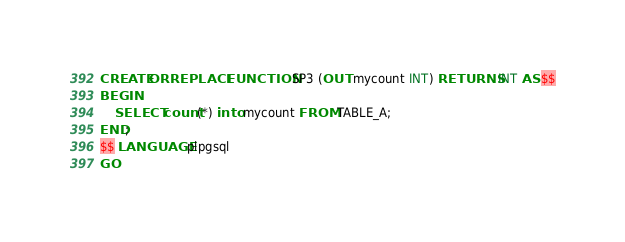<code> <loc_0><loc_0><loc_500><loc_500><_SQL_>CREATE OR REPLACE FUNCTION SP3 (OUT mycount INT) RETURNS INT AS $$
BEGIN
    SELECT count(*) into mycount FROM TABLE_A;
END;
$$ LANGUAGE plpgsql
GO</code> 